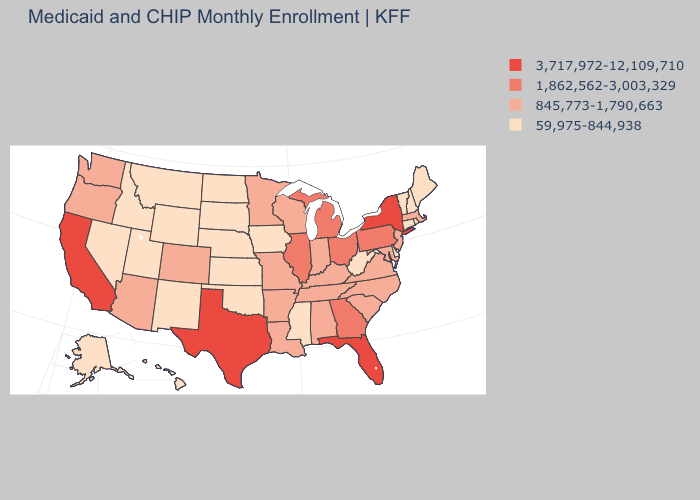Among the states that border Rhode Island , which have the highest value?
Short answer required. Massachusetts. Which states have the highest value in the USA?
Answer briefly. California, Florida, New York, Texas. Does California have the highest value in the West?
Short answer required. Yes. What is the highest value in the USA?
Answer briefly. 3,717,972-12,109,710. Which states have the lowest value in the MidWest?
Keep it brief. Iowa, Kansas, Nebraska, North Dakota, South Dakota. What is the value of Florida?
Give a very brief answer. 3,717,972-12,109,710. Name the states that have a value in the range 1,862,562-3,003,329?
Write a very short answer. Georgia, Illinois, Michigan, Ohio, Pennsylvania. Which states have the lowest value in the South?
Be succinct. Delaware, Mississippi, Oklahoma, West Virginia. What is the value of Georgia?
Short answer required. 1,862,562-3,003,329. Among the states that border Alabama , does Mississippi have the lowest value?
Answer briefly. Yes. Among the states that border Tennessee , does Georgia have the highest value?
Answer briefly. Yes. What is the value of Massachusetts?
Answer briefly. 845,773-1,790,663. Name the states that have a value in the range 845,773-1,790,663?
Concise answer only. Alabama, Arizona, Arkansas, Colorado, Indiana, Kentucky, Louisiana, Maryland, Massachusetts, Minnesota, Missouri, New Jersey, North Carolina, Oregon, South Carolina, Tennessee, Virginia, Washington, Wisconsin. What is the lowest value in the West?
Answer briefly. 59,975-844,938. 